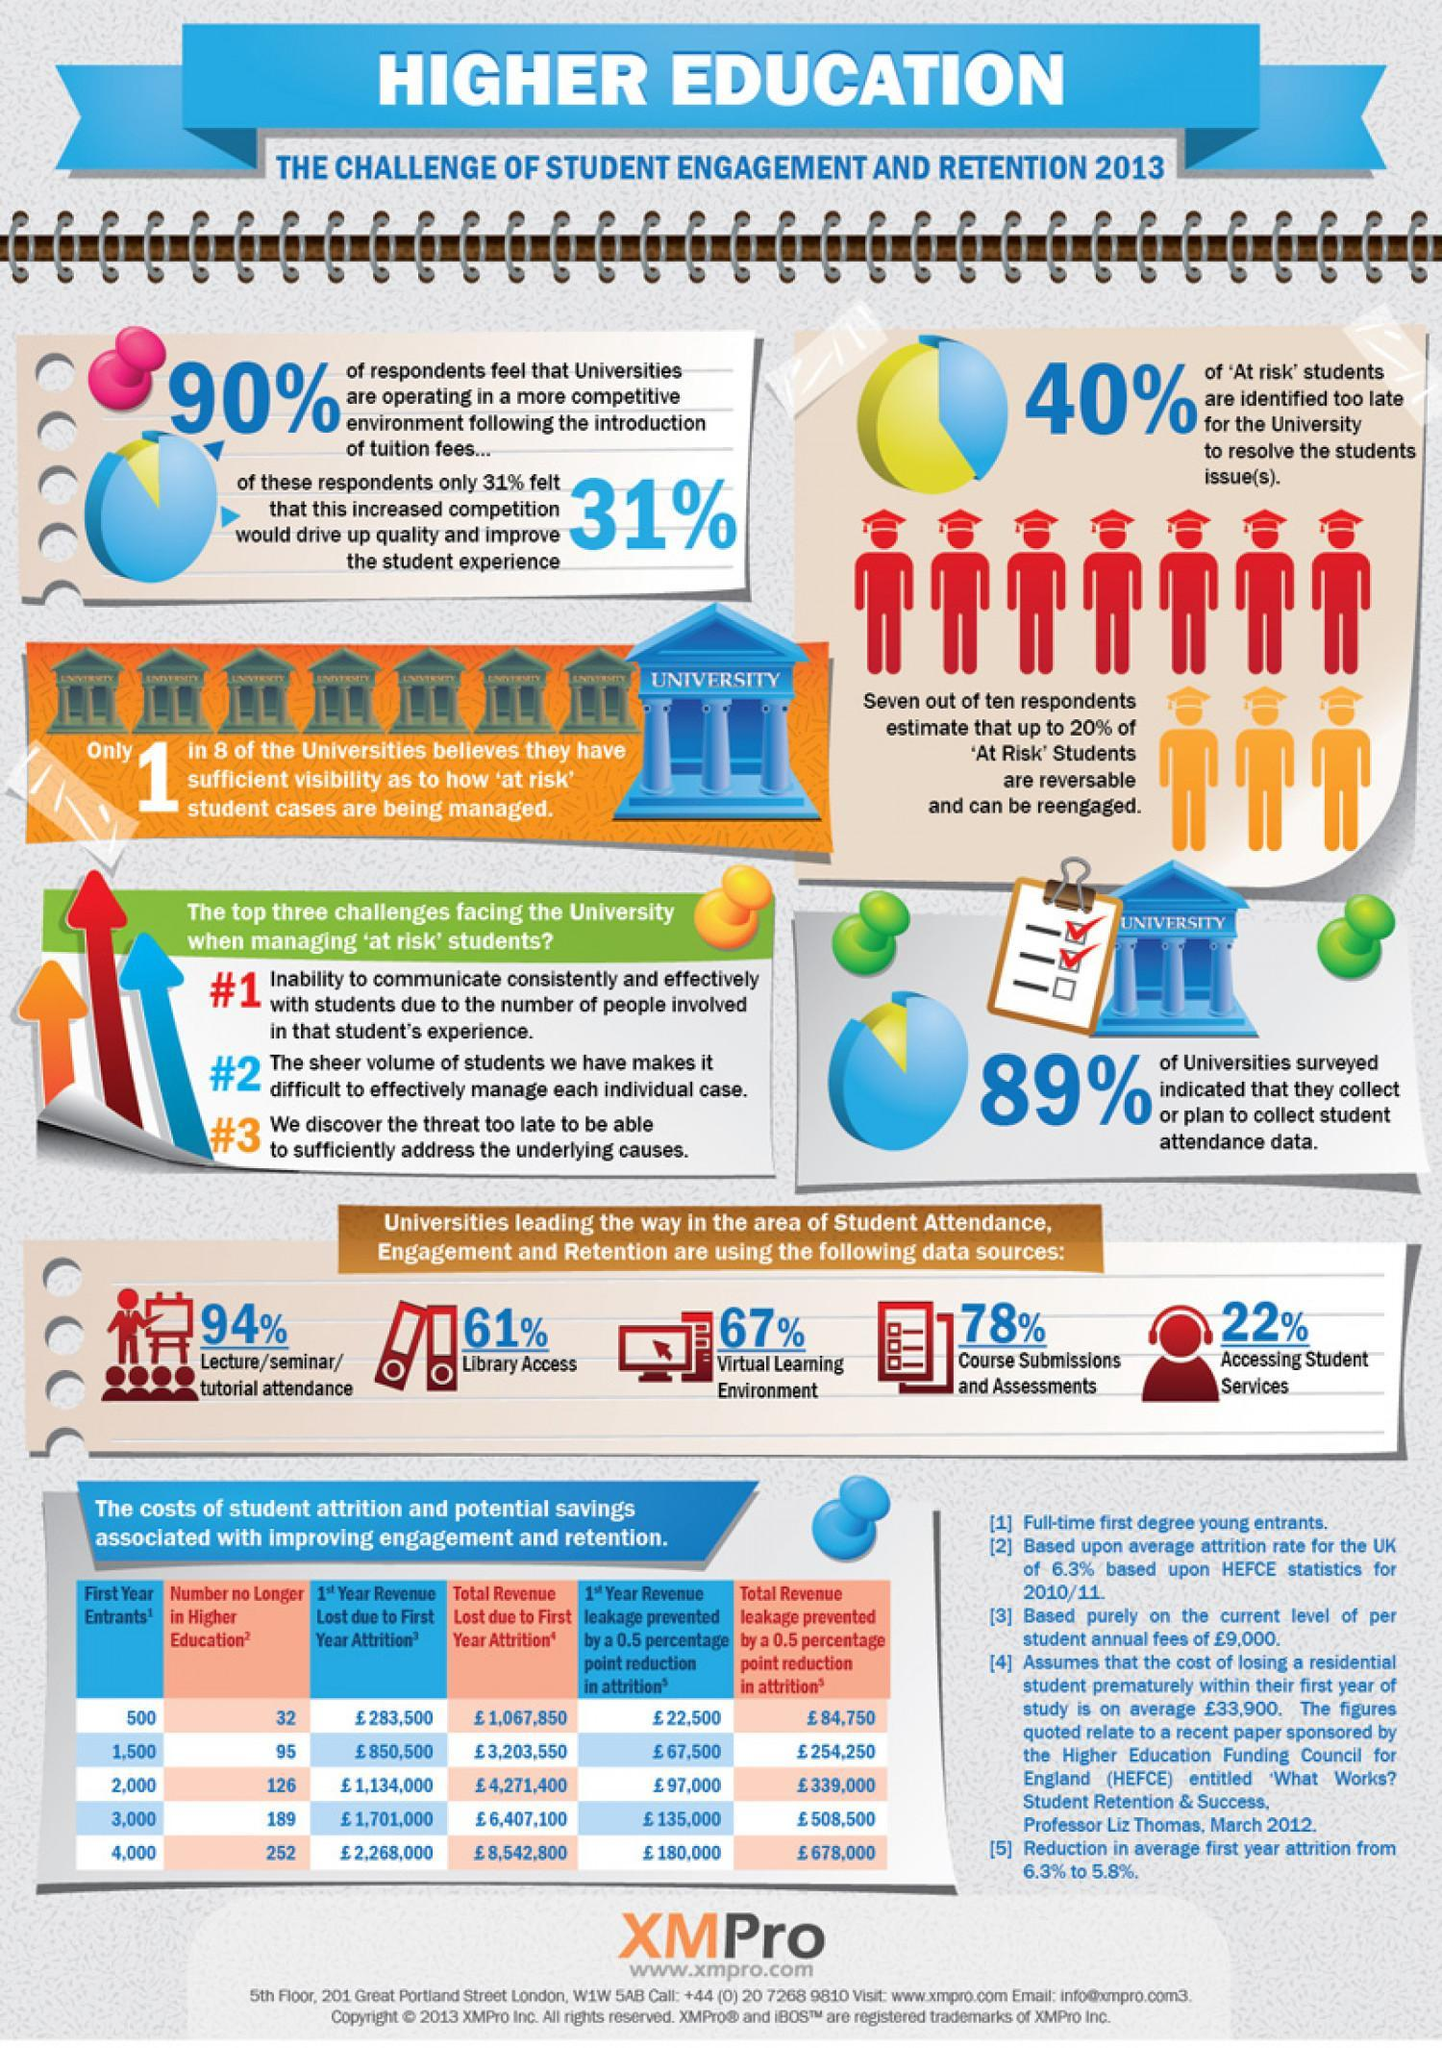Which is the first and major most challenge faced by universities when managing 'at risk' students?
Answer the question with a short phrase. Inability to communicate consistently and effectively According to the survey, what percentage of universities collect or have plans to collect student attendance data? 89% 